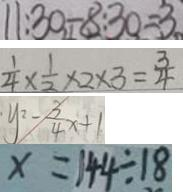Convert formula to latex. <formula><loc_0><loc_0><loc_500><loc_500>1 1 . 3 0 - 8 . 3 0 = 3 
 \frac { 1 } { 4 } \times \frac { 1 } { 2 } \times 2 \times 3 = \frac { 3 } { 4 } 
 y ^ { 2 } - \frac { 3 } { 4 } x + 1 
 x = 1 4 4 \div 1 8</formula> 